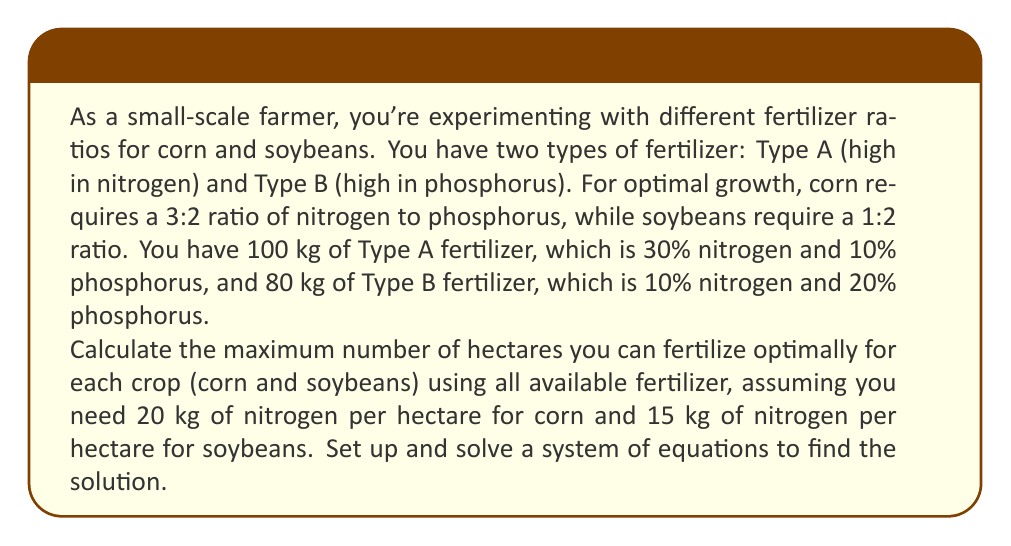Can you answer this question? Let's approach this problem step by step:

1) First, let's define our variables:
   $x$ = kg of Type A fertilizer used
   $y$ = kg of Type B fertilizer used

2) Now, let's calculate the amounts of nitrogen (N) and phosphorus (P) in each type of fertilizer:
   Type A: 30% N, 10% P
   Type B: 10% N, 20% P

3) For corn (3:2 ratio of N:P), we can set up the equation:
   $$\frac{0.3x + 0.1y}{0.1x + 0.2y} = \frac{3}{2}$$

4) For soybeans (1:2 ratio of N:P), we can set up the equation:
   $$\frac{0.3x + 0.1y}{0.1x + 0.2y} = \frac{1}{2}$$

5) We also know that we're using all the fertilizer, so:
   $$x + y = 180$$

6) Let's focus on the corn equation. Cross-multiplying:
   $$(0.3x + 0.1y) \cdot 2 = (0.1x + 0.2y) \cdot 3$$
   $$0.6x + 0.2y = 0.3x + 0.6y$$
   $$0.3x = 0.4y$$
   $$x = \frac{4}{3}y$$

7) Substituting this into the total fertilizer equation:
   $$\frac{4}{3}y + y = 180$$
   $$\frac{7}{3}y = 180$$
   $$y = \frac{180 \cdot 3}{7} = 77.14$$
   $$x = 180 - 77.14 = 102.86$$

8) Now we know the optimal mix for corn. Let's calculate how much nitrogen this provides:
   $$(102.86 \cdot 0.3) + (77.14 \cdot 0.1) = 30.86 + 7.71 = 38.57$$ kg of N

9) Since corn needs 20 kg of N per hectare, we can fertilize:
   $$38.57 / 20 = 1.93$$ hectares of corn

10) For soybeans, we can use the same fertilizer mix but in different proportions:
    $$(102.86 \cdot 0.3) + (77.14 \cdot 0.1) = 30.86 + 7.71 = 38.57$$ kg of N

11) Since soybeans need 15 kg of N per hectare, we can fertilize:
    $$38.57 / 15 = 2.57$$ hectares of soybeans
Answer: Using all available fertilizer, you can optimally fertilize 1.93 hectares of corn or 2.57 hectares of soybeans. 